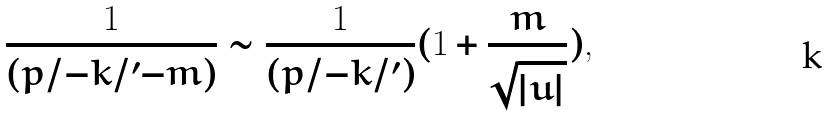Convert formula to latex. <formula><loc_0><loc_0><loc_500><loc_500>\frac { 1 } { ( p / - k / ^ { \prime } - m ) } \sim \frac { 1 } { ( p / - k / ^ { \prime } ) } ( 1 + \frac { m } { \sqrt { | u | } } ) ,</formula> 